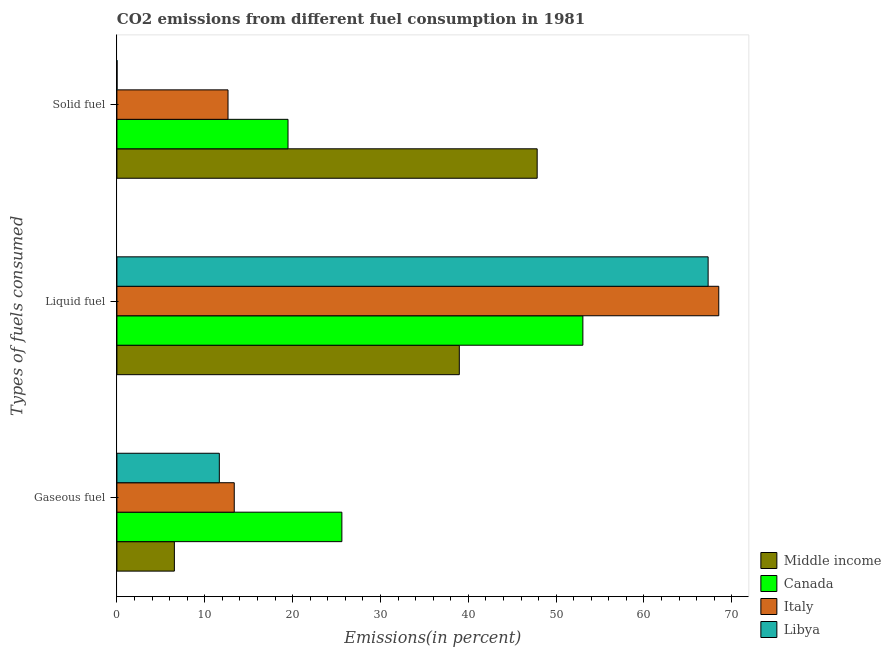How many different coloured bars are there?
Ensure brevity in your answer.  4. Are the number of bars per tick equal to the number of legend labels?
Offer a very short reply. Yes. How many bars are there on the 1st tick from the bottom?
Your answer should be very brief. 4. What is the label of the 3rd group of bars from the top?
Offer a very short reply. Gaseous fuel. What is the percentage of liquid fuel emission in Canada?
Offer a terse response. 53.04. Across all countries, what is the maximum percentage of solid fuel emission?
Your response must be concise. 47.84. Across all countries, what is the minimum percentage of gaseous fuel emission?
Offer a very short reply. 6.54. What is the total percentage of liquid fuel emission in the graph?
Make the answer very short. 227.84. What is the difference between the percentage of gaseous fuel emission in Libya and that in Middle income?
Keep it short and to the point. 5.12. What is the difference between the percentage of liquid fuel emission in Libya and the percentage of gaseous fuel emission in Italy?
Your answer should be compact. 53.95. What is the average percentage of liquid fuel emission per country?
Ensure brevity in your answer.  56.96. What is the difference between the percentage of solid fuel emission and percentage of gaseous fuel emission in Italy?
Your answer should be compact. -0.71. What is the ratio of the percentage of gaseous fuel emission in Canada to that in Middle income?
Your response must be concise. 3.91. Is the difference between the percentage of gaseous fuel emission in Middle income and Libya greater than the difference between the percentage of liquid fuel emission in Middle income and Libya?
Your answer should be very brief. Yes. What is the difference between the highest and the second highest percentage of solid fuel emission?
Provide a short and direct response. 28.36. What is the difference between the highest and the lowest percentage of liquid fuel emission?
Your answer should be very brief. 29.54. Is it the case that in every country, the sum of the percentage of gaseous fuel emission and percentage of liquid fuel emission is greater than the percentage of solid fuel emission?
Give a very brief answer. No. Are all the bars in the graph horizontal?
Give a very brief answer. Yes. How many countries are there in the graph?
Give a very brief answer. 4. Does the graph contain any zero values?
Provide a succinct answer. No. Does the graph contain grids?
Make the answer very short. No. How many legend labels are there?
Make the answer very short. 4. What is the title of the graph?
Keep it short and to the point. CO2 emissions from different fuel consumption in 1981. Does "Norway" appear as one of the legend labels in the graph?
Provide a short and direct response. No. What is the label or title of the X-axis?
Ensure brevity in your answer.  Emissions(in percent). What is the label or title of the Y-axis?
Your answer should be compact. Types of fuels consumed. What is the Emissions(in percent) of Middle income in Gaseous fuel?
Offer a terse response. 6.54. What is the Emissions(in percent) in Canada in Gaseous fuel?
Offer a terse response. 25.61. What is the Emissions(in percent) of Italy in Gaseous fuel?
Offer a terse response. 13.36. What is the Emissions(in percent) in Libya in Gaseous fuel?
Your response must be concise. 11.66. What is the Emissions(in percent) in Middle income in Liquid fuel?
Offer a very short reply. 38.98. What is the Emissions(in percent) in Canada in Liquid fuel?
Offer a very short reply. 53.04. What is the Emissions(in percent) of Italy in Liquid fuel?
Provide a short and direct response. 68.51. What is the Emissions(in percent) in Libya in Liquid fuel?
Give a very brief answer. 67.3. What is the Emissions(in percent) in Middle income in Solid fuel?
Offer a terse response. 47.84. What is the Emissions(in percent) in Canada in Solid fuel?
Give a very brief answer. 19.48. What is the Emissions(in percent) in Italy in Solid fuel?
Your answer should be compact. 12.65. What is the Emissions(in percent) in Libya in Solid fuel?
Provide a short and direct response. 0.01. Across all Types of fuels consumed, what is the maximum Emissions(in percent) of Middle income?
Provide a short and direct response. 47.84. Across all Types of fuels consumed, what is the maximum Emissions(in percent) in Canada?
Your response must be concise. 53.04. Across all Types of fuels consumed, what is the maximum Emissions(in percent) in Italy?
Give a very brief answer. 68.51. Across all Types of fuels consumed, what is the maximum Emissions(in percent) of Libya?
Offer a terse response. 67.3. Across all Types of fuels consumed, what is the minimum Emissions(in percent) of Middle income?
Provide a short and direct response. 6.54. Across all Types of fuels consumed, what is the minimum Emissions(in percent) of Canada?
Give a very brief answer. 19.48. Across all Types of fuels consumed, what is the minimum Emissions(in percent) in Italy?
Make the answer very short. 12.65. Across all Types of fuels consumed, what is the minimum Emissions(in percent) of Libya?
Provide a succinct answer. 0.01. What is the total Emissions(in percent) of Middle income in the graph?
Your response must be concise. 93.36. What is the total Emissions(in percent) in Canada in the graph?
Offer a terse response. 98.13. What is the total Emissions(in percent) of Italy in the graph?
Keep it short and to the point. 94.52. What is the total Emissions(in percent) in Libya in the graph?
Provide a short and direct response. 78.97. What is the difference between the Emissions(in percent) of Middle income in Gaseous fuel and that in Liquid fuel?
Ensure brevity in your answer.  -32.44. What is the difference between the Emissions(in percent) in Canada in Gaseous fuel and that in Liquid fuel?
Offer a terse response. -27.44. What is the difference between the Emissions(in percent) of Italy in Gaseous fuel and that in Liquid fuel?
Your answer should be very brief. -55.16. What is the difference between the Emissions(in percent) in Libya in Gaseous fuel and that in Liquid fuel?
Provide a short and direct response. -55.64. What is the difference between the Emissions(in percent) in Middle income in Gaseous fuel and that in Solid fuel?
Give a very brief answer. -41.3. What is the difference between the Emissions(in percent) in Canada in Gaseous fuel and that in Solid fuel?
Make the answer very short. 6.13. What is the difference between the Emissions(in percent) in Italy in Gaseous fuel and that in Solid fuel?
Offer a very short reply. 0.71. What is the difference between the Emissions(in percent) in Libya in Gaseous fuel and that in Solid fuel?
Provide a short and direct response. 11.65. What is the difference between the Emissions(in percent) of Middle income in Liquid fuel and that in Solid fuel?
Give a very brief answer. -8.86. What is the difference between the Emissions(in percent) of Canada in Liquid fuel and that in Solid fuel?
Ensure brevity in your answer.  33.57. What is the difference between the Emissions(in percent) in Italy in Liquid fuel and that in Solid fuel?
Offer a very short reply. 55.87. What is the difference between the Emissions(in percent) of Libya in Liquid fuel and that in Solid fuel?
Ensure brevity in your answer.  67.29. What is the difference between the Emissions(in percent) of Middle income in Gaseous fuel and the Emissions(in percent) of Canada in Liquid fuel?
Your response must be concise. -46.5. What is the difference between the Emissions(in percent) in Middle income in Gaseous fuel and the Emissions(in percent) in Italy in Liquid fuel?
Provide a succinct answer. -61.97. What is the difference between the Emissions(in percent) in Middle income in Gaseous fuel and the Emissions(in percent) in Libya in Liquid fuel?
Your answer should be very brief. -60.76. What is the difference between the Emissions(in percent) of Canada in Gaseous fuel and the Emissions(in percent) of Italy in Liquid fuel?
Provide a succinct answer. -42.91. What is the difference between the Emissions(in percent) in Canada in Gaseous fuel and the Emissions(in percent) in Libya in Liquid fuel?
Make the answer very short. -41.69. What is the difference between the Emissions(in percent) in Italy in Gaseous fuel and the Emissions(in percent) in Libya in Liquid fuel?
Ensure brevity in your answer.  -53.95. What is the difference between the Emissions(in percent) of Middle income in Gaseous fuel and the Emissions(in percent) of Canada in Solid fuel?
Keep it short and to the point. -12.94. What is the difference between the Emissions(in percent) in Middle income in Gaseous fuel and the Emissions(in percent) in Italy in Solid fuel?
Give a very brief answer. -6.11. What is the difference between the Emissions(in percent) in Middle income in Gaseous fuel and the Emissions(in percent) in Libya in Solid fuel?
Your response must be concise. 6.53. What is the difference between the Emissions(in percent) of Canada in Gaseous fuel and the Emissions(in percent) of Italy in Solid fuel?
Your answer should be compact. 12.96. What is the difference between the Emissions(in percent) in Canada in Gaseous fuel and the Emissions(in percent) in Libya in Solid fuel?
Provide a short and direct response. 25.6. What is the difference between the Emissions(in percent) in Italy in Gaseous fuel and the Emissions(in percent) in Libya in Solid fuel?
Keep it short and to the point. 13.34. What is the difference between the Emissions(in percent) of Middle income in Liquid fuel and the Emissions(in percent) of Canada in Solid fuel?
Offer a terse response. 19.5. What is the difference between the Emissions(in percent) of Middle income in Liquid fuel and the Emissions(in percent) of Italy in Solid fuel?
Your answer should be compact. 26.33. What is the difference between the Emissions(in percent) of Middle income in Liquid fuel and the Emissions(in percent) of Libya in Solid fuel?
Ensure brevity in your answer.  38.96. What is the difference between the Emissions(in percent) of Canada in Liquid fuel and the Emissions(in percent) of Italy in Solid fuel?
Offer a very short reply. 40.4. What is the difference between the Emissions(in percent) of Canada in Liquid fuel and the Emissions(in percent) of Libya in Solid fuel?
Provide a short and direct response. 53.03. What is the difference between the Emissions(in percent) of Italy in Liquid fuel and the Emissions(in percent) of Libya in Solid fuel?
Provide a succinct answer. 68.5. What is the average Emissions(in percent) in Middle income per Types of fuels consumed?
Your answer should be compact. 31.12. What is the average Emissions(in percent) of Canada per Types of fuels consumed?
Offer a very short reply. 32.71. What is the average Emissions(in percent) of Italy per Types of fuels consumed?
Your answer should be compact. 31.51. What is the average Emissions(in percent) in Libya per Types of fuels consumed?
Ensure brevity in your answer.  26.32. What is the difference between the Emissions(in percent) in Middle income and Emissions(in percent) in Canada in Gaseous fuel?
Your response must be concise. -19.07. What is the difference between the Emissions(in percent) of Middle income and Emissions(in percent) of Italy in Gaseous fuel?
Your response must be concise. -6.82. What is the difference between the Emissions(in percent) of Middle income and Emissions(in percent) of Libya in Gaseous fuel?
Keep it short and to the point. -5.12. What is the difference between the Emissions(in percent) in Canada and Emissions(in percent) in Italy in Gaseous fuel?
Your response must be concise. 12.25. What is the difference between the Emissions(in percent) of Canada and Emissions(in percent) of Libya in Gaseous fuel?
Keep it short and to the point. 13.95. What is the difference between the Emissions(in percent) in Italy and Emissions(in percent) in Libya in Gaseous fuel?
Provide a succinct answer. 1.7. What is the difference between the Emissions(in percent) of Middle income and Emissions(in percent) of Canada in Liquid fuel?
Make the answer very short. -14.07. What is the difference between the Emissions(in percent) in Middle income and Emissions(in percent) in Italy in Liquid fuel?
Your response must be concise. -29.54. What is the difference between the Emissions(in percent) of Middle income and Emissions(in percent) of Libya in Liquid fuel?
Your response must be concise. -28.33. What is the difference between the Emissions(in percent) of Canada and Emissions(in percent) of Italy in Liquid fuel?
Provide a succinct answer. -15.47. What is the difference between the Emissions(in percent) of Canada and Emissions(in percent) of Libya in Liquid fuel?
Provide a succinct answer. -14.26. What is the difference between the Emissions(in percent) of Italy and Emissions(in percent) of Libya in Liquid fuel?
Offer a terse response. 1.21. What is the difference between the Emissions(in percent) in Middle income and Emissions(in percent) in Canada in Solid fuel?
Keep it short and to the point. 28.36. What is the difference between the Emissions(in percent) in Middle income and Emissions(in percent) in Italy in Solid fuel?
Provide a succinct answer. 35.19. What is the difference between the Emissions(in percent) of Middle income and Emissions(in percent) of Libya in Solid fuel?
Your answer should be compact. 47.83. What is the difference between the Emissions(in percent) in Canada and Emissions(in percent) in Italy in Solid fuel?
Ensure brevity in your answer.  6.83. What is the difference between the Emissions(in percent) in Canada and Emissions(in percent) in Libya in Solid fuel?
Give a very brief answer. 19.47. What is the difference between the Emissions(in percent) in Italy and Emissions(in percent) in Libya in Solid fuel?
Your answer should be compact. 12.63. What is the ratio of the Emissions(in percent) in Middle income in Gaseous fuel to that in Liquid fuel?
Give a very brief answer. 0.17. What is the ratio of the Emissions(in percent) of Canada in Gaseous fuel to that in Liquid fuel?
Offer a very short reply. 0.48. What is the ratio of the Emissions(in percent) of Italy in Gaseous fuel to that in Liquid fuel?
Keep it short and to the point. 0.19. What is the ratio of the Emissions(in percent) in Libya in Gaseous fuel to that in Liquid fuel?
Ensure brevity in your answer.  0.17. What is the ratio of the Emissions(in percent) of Middle income in Gaseous fuel to that in Solid fuel?
Ensure brevity in your answer.  0.14. What is the ratio of the Emissions(in percent) in Canada in Gaseous fuel to that in Solid fuel?
Keep it short and to the point. 1.31. What is the ratio of the Emissions(in percent) of Italy in Gaseous fuel to that in Solid fuel?
Make the answer very short. 1.06. What is the ratio of the Emissions(in percent) in Libya in Gaseous fuel to that in Solid fuel?
Keep it short and to the point. 916. What is the ratio of the Emissions(in percent) of Middle income in Liquid fuel to that in Solid fuel?
Your answer should be compact. 0.81. What is the ratio of the Emissions(in percent) of Canada in Liquid fuel to that in Solid fuel?
Offer a terse response. 2.72. What is the ratio of the Emissions(in percent) of Italy in Liquid fuel to that in Solid fuel?
Give a very brief answer. 5.42. What is the ratio of the Emissions(in percent) in Libya in Liquid fuel to that in Solid fuel?
Offer a terse response. 5288. What is the difference between the highest and the second highest Emissions(in percent) of Middle income?
Your answer should be very brief. 8.86. What is the difference between the highest and the second highest Emissions(in percent) of Canada?
Keep it short and to the point. 27.44. What is the difference between the highest and the second highest Emissions(in percent) of Italy?
Offer a very short reply. 55.16. What is the difference between the highest and the second highest Emissions(in percent) of Libya?
Ensure brevity in your answer.  55.64. What is the difference between the highest and the lowest Emissions(in percent) of Middle income?
Your response must be concise. 41.3. What is the difference between the highest and the lowest Emissions(in percent) in Canada?
Provide a succinct answer. 33.57. What is the difference between the highest and the lowest Emissions(in percent) in Italy?
Your response must be concise. 55.87. What is the difference between the highest and the lowest Emissions(in percent) in Libya?
Make the answer very short. 67.29. 